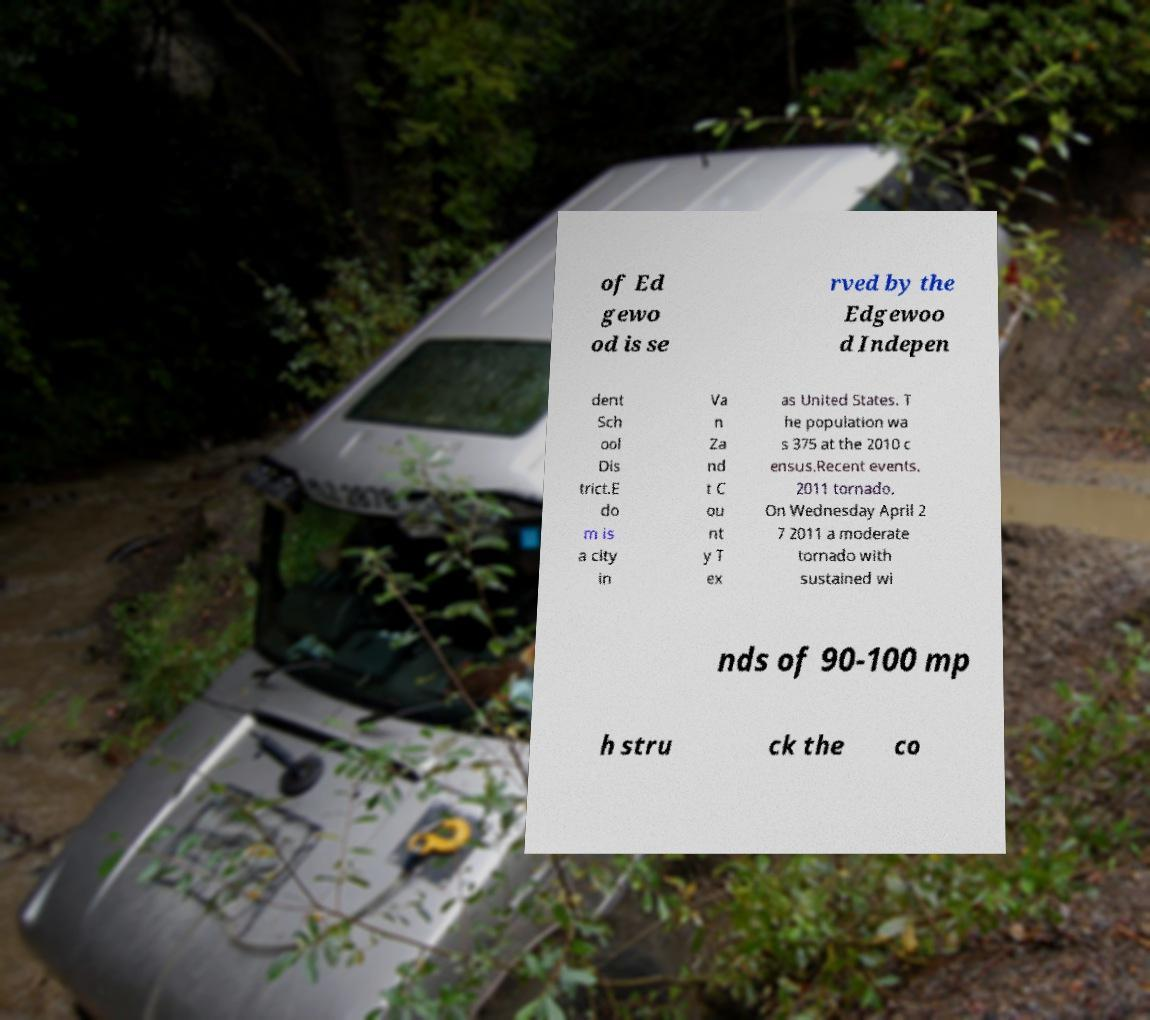Please read and relay the text visible in this image. What does it say? of Ed gewo od is se rved by the Edgewoo d Indepen dent Sch ool Dis trict.E do m is a city in Va n Za nd t C ou nt y T ex as United States. T he population wa s 375 at the 2010 c ensus.Recent events. 2011 tornado. On Wednesday April 2 7 2011 a moderate tornado with sustained wi nds of 90-100 mp h stru ck the co 